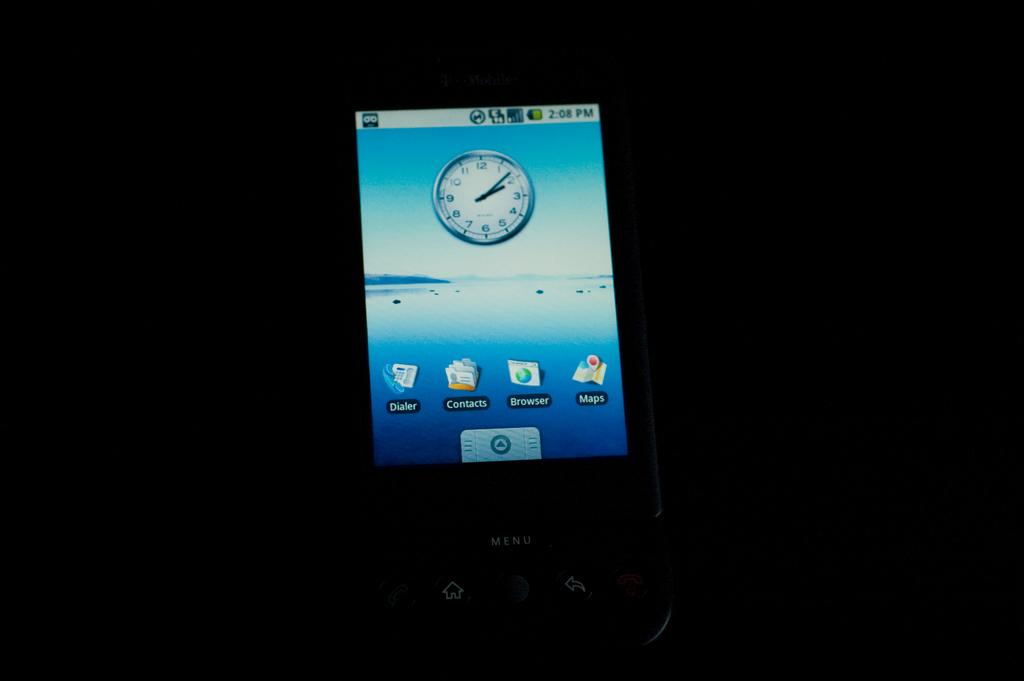<image>
Create a compact narrative representing the image presented. A phone screen says that the current time is 2:08 PM. 